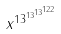Convert formula to latex. <formula><loc_0><loc_0><loc_500><loc_500>x ^ { 1 3 ^ { 1 3 ^ { 1 3 ^ { 1 2 2 } } } }</formula> 